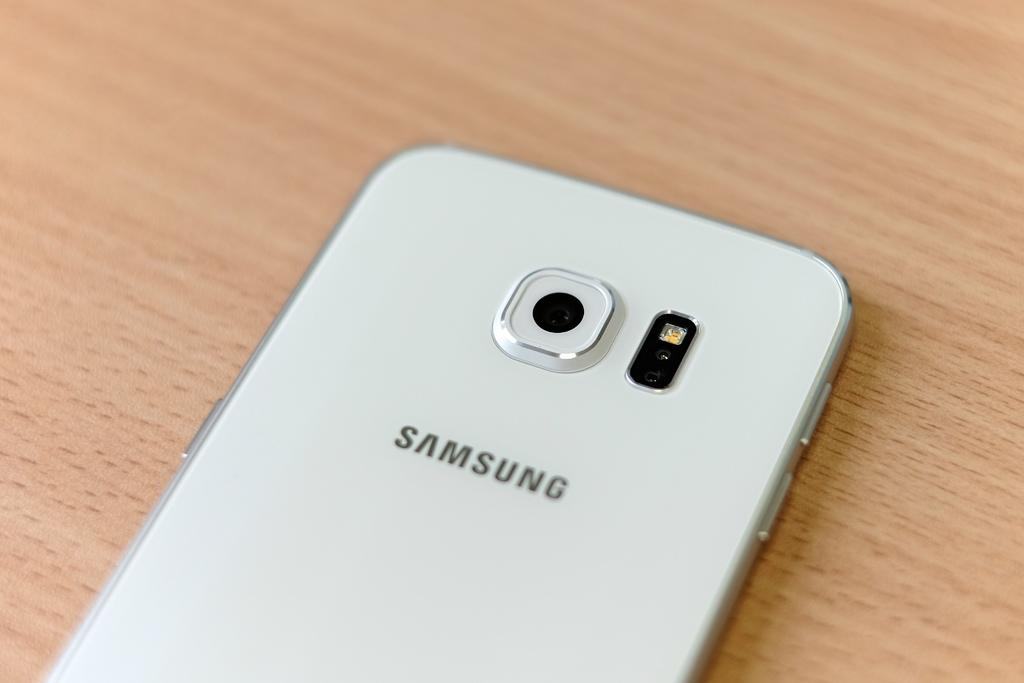<image>
Offer a succinct explanation of the picture presented. the back of a white Samsung cell phone 